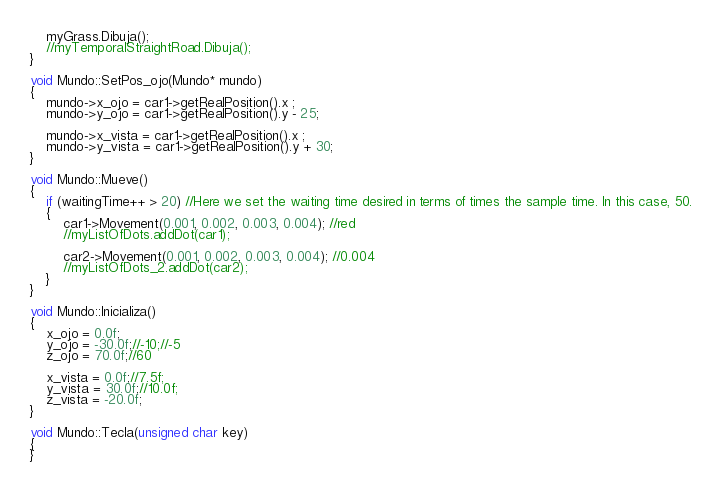Convert code to text. <code><loc_0><loc_0><loc_500><loc_500><_C++_>	myGrass.Dibuja(); 
	//myTemporalStraightRoad.Dibuja();
}

void Mundo::SetPos_ojo(Mundo* mundo)
{
	mundo->x_ojo = car1->getRealPosition().x ;
	mundo->y_ojo = car1->getRealPosition().y - 25;

	mundo->x_vista = car1->getRealPosition().x ;
	mundo->y_vista = car1->getRealPosition().y + 30;
}

void Mundo::Mueve()
{
	if (waitingTime++ > 20) //Here we set the waiting time desired in terms of times the sample time. In this case, 50.
	{
		car1->Movement(0.001, 0.002, 0.003, 0.004); //red
		//myListOfDots.addDot(car1);

		car2->Movement(0.001, 0.002, 0.003, 0.004); //0.004
		//myListOfDots_2.addDot(car2);
	}
}

void Mundo::Inicializa()
{
	x_ojo = 0.0f;
	y_ojo = -30.0f;//-10;//-5
	z_ojo = 70.0f;//60

	x_vista = 0.0f;//7.5f;
	y_vista = 30.0f;//10.0f;
	z_vista = -20.0f;
}

void Mundo::Tecla(unsigned char key)
{
}</code> 